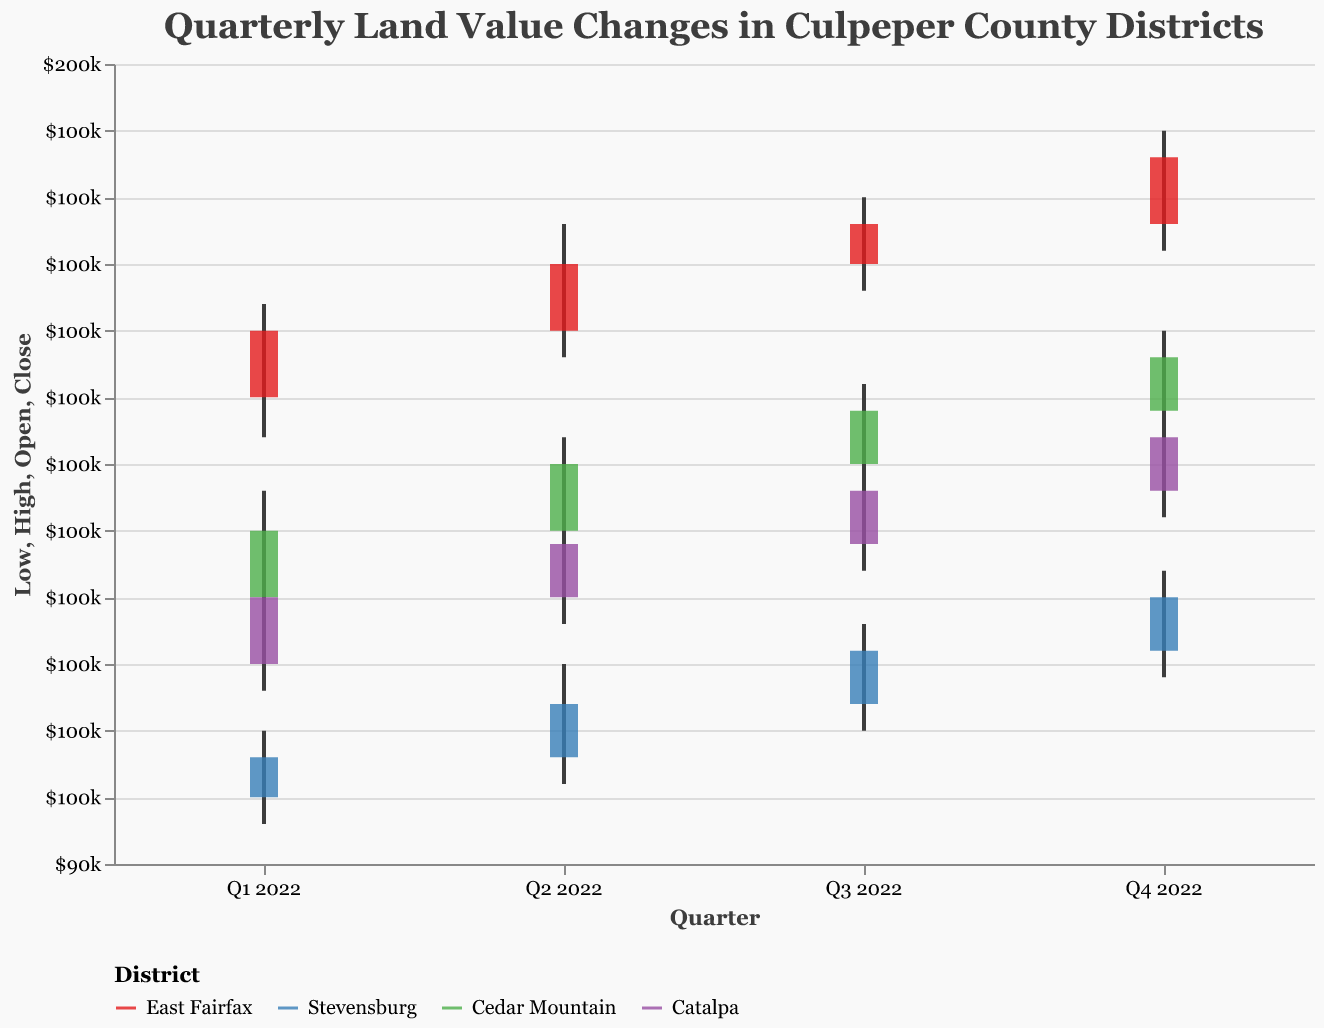What is the closing land value in East Fairfax for Q4 2022? The figure shows the closing land value for each district and quarter. For East Fairfax in Q4 2022, the closing value is marked at the end of the bar.
Answer: 143,000 Which district has the highest closing value in Q4 2022? By looking at the closing values in all districts for Q4 2022, the highest closing value is found in East Fairfax.
Answer: East Fairfax How did the land value in Stevensburg change from Q1 2022 to Q4 2022? To determine the change, subtract the closing value of Q1 2022 from the closing value of Q4 2022 in Stevensburg. Q4 2022: 110,000, Q1 2022: 98,000. The change is 110,000 - 98,000.
Answer: Increased by 12,000 Which quarter had the lowest closing value for Catalpa? By comparing all the quarters' closing values for Catalpa, Q1 2022 with a closing value of 110,000 is the lowest.
Answer: Q1 2022 What was the average land value in Cedar Mountain over the four quarters? Sum the closing values for Cedar Mountain for all four quarters and divide by 4. (115,000 + 120,000 + 124,000 + 128,000) / 4 = 121,750.
Answer: 121,750 Compare the high values for Catalpa and East Fairfax in Q3 2022. Which district had a higher value and by how much? The high value for Catalpa in Q3 2022 is 120,000 and for East Fairfax is 140,000. The difference is 140,000 - 120,000. East Fairfax had the higher value.
Answer: East Fairfax by 20,000 What is the trend observed in the quarterly land values for Cedar Mountain? The closing values show a consistent increase each quarter: Q1 2022 (115,000), Q2 2022 (120,000), Q3 2022 (124,000), Q4 2022 (128,000). This indicates a rising trend.
Answer: Increasing trend In which quarter did Stevensburg see the highest fluctuation in land value? Fluctuation can be determined by the difference between high and low values within the same quarter. In Stevensburg, Q2 2022 has the highest fluctuation (105,000 - 96,000 = 9,000).
Answer: Q2 2022 How much did the land value increase in East Fairfax from Q3 to Q4 in 2022? Subtract the closing value of Q3 2022 from the closing value of Q4 2022 for East Fairfax. Q4 2022: 143,000, Q3 2022: 138,000. The increase is 143,000 - 138,000.
Answer: Increased by 5,000 